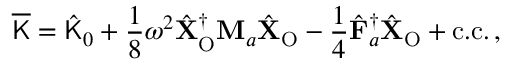<formula> <loc_0><loc_0><loc_500><loc_500>\overline { K } = \hat { K } _ { 0 } + \frac { 1 } { 8 } \omega ^ { 2 } \hat { X } _ { O } ^ { \dagger } M _ { a } \hat { X } _ { O } - \frac { 1 } { 4 } \hat { F } _ { a } ^ { \dagger } \hat { X } _ { O } + c . c . \, ,</formula> 